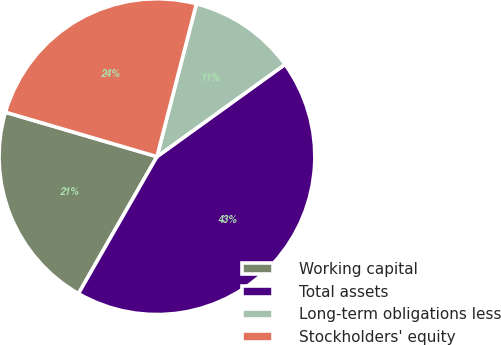<chart> <loc_0><loc_0><loc_500><loc_500><pie_chart><fcel>Working capital<fcel>Total assets<fcel>Long-term obligations less<fcel>Stockholders' equity<nl><fcel>21.26%<fcel>43.22%<fcel>11.04%<fcel>24.48%<nl></chart> 